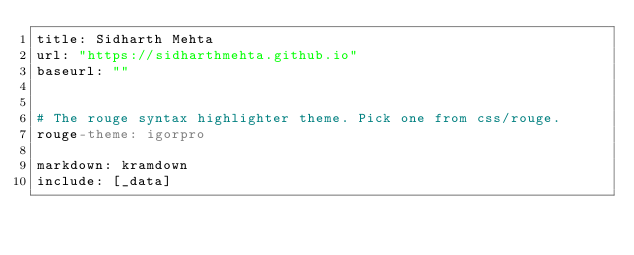<code> <loc_0><loc_0><loc_500><loc_500><_YAML_>title: Sidharth Mehta
url: "https://sidharthmehta.github.io"
baseurl: ""


# The rouge syntax highlighter theme. Pick one from css/rouge.
rouge-theme: igorpro

markdown: kramdown
include: [_data]
</code> 